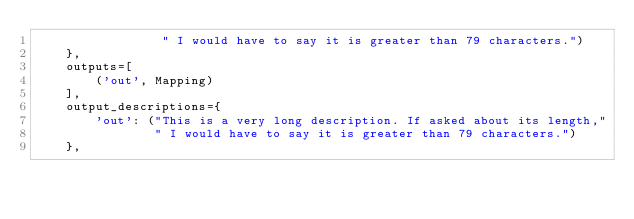Convert code to text. <code><loc_0><loc_0><loc_500><loc_500><_Python_>                 " I would have to say it is greater than 79 characters.")
    },
    outputs=[
        ('out', Mapping)
    ],
    output_descriptions={
        'out': ("This is a very long description. If asked about its length,"
                " I would have to say it is greater than 79 characters.")
    },</code> 